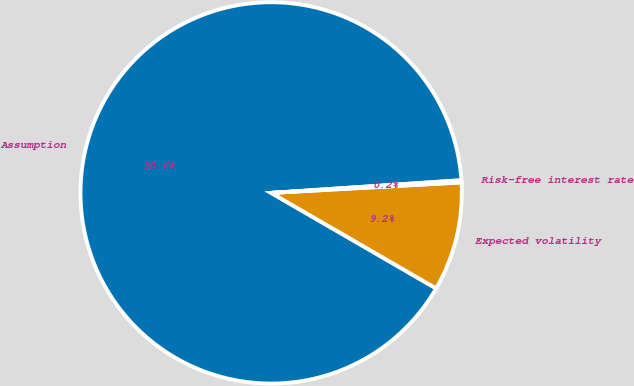Convert chart. <chart><loc_0><loc_0><loc_500><loc_500><pie_chart><fcel>Assumption<fcel>Expected volatility<fcel>Risk-free interest rate<nl><fcel>90.59%<fcel>9.23%<fcel>0.18%<nl></chart> 